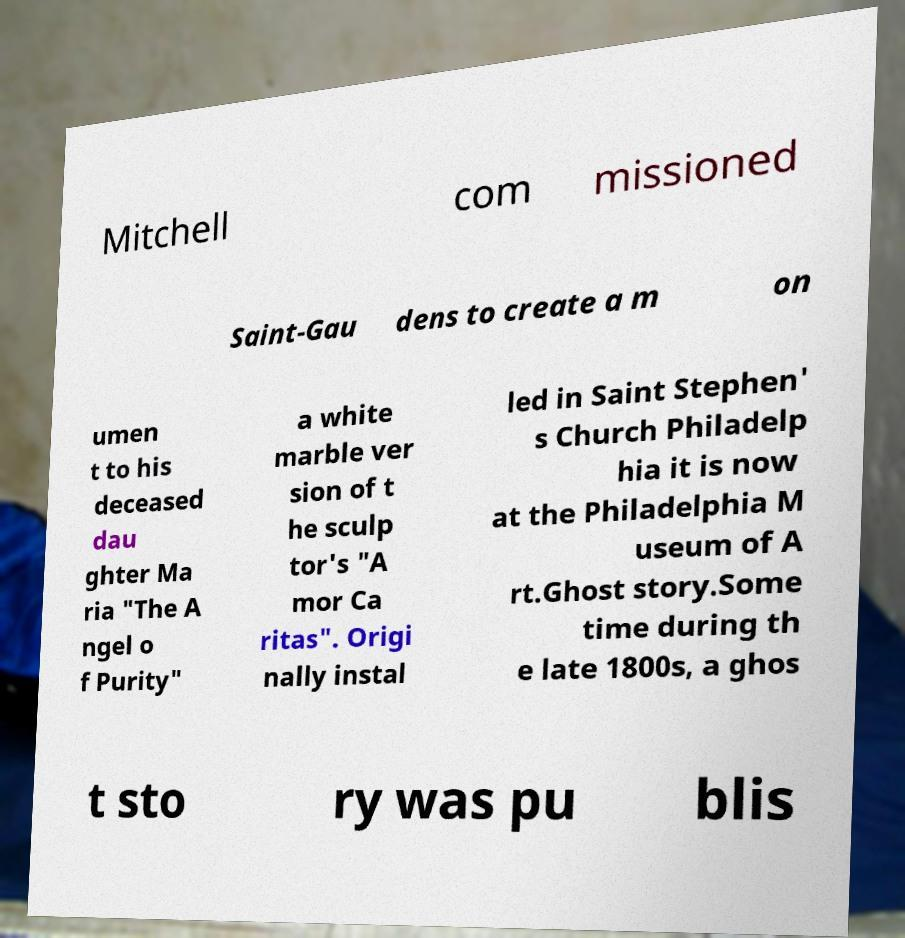Can you read and provide the text displayed in the image?This photo seems to have some interesting text. Can you extract and type it out for me? Mitchell com missioned Saint-Gau dens to create a m on umen t to his deceased dau ghter Ma ria "The A ngel o f Purity" a white marble ver sion of t he sculp tor's "A mor Ca ritas". Origi nally instal led in Saint Stephen' s Church Philadelp hia it is now at the Philadelphia M useum of A rt.Ghost story.Some time during th e late 1800s, a ghos t sto ry was pu blis 